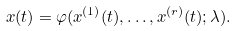<formula> <loc_0><loc_0><loc_500><loc_500>x ( t ) = \varphi ( x ^ { ( 1 ) } ( t ) , \dots , x ^ { ( r ) } ( t ) ; \lambda ) .</formula> 